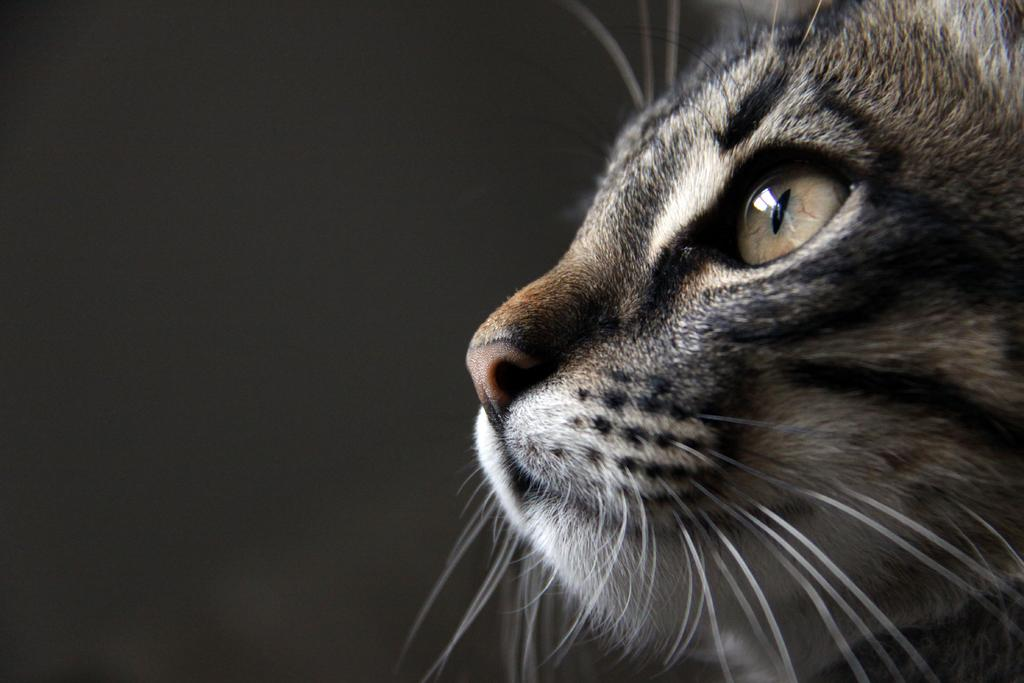What is the main subject of the picture? The main subject of the picture is a cat face. What distinguishing feature does the cat face have? The cat face has a mustache. How many eyes does the cat face have? The cat face has one eye. What is another facial feature present on the cat face? The cat face has a nose. How many pigs can be seen swimming in the waves in the image? There are no pigs or waves present in the image; it features a cat face with a mustache, eye, and nose. 